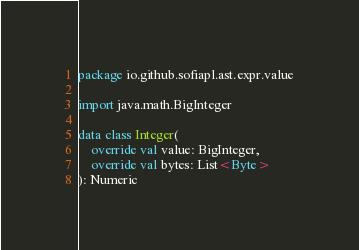Convert code to text. <code><loc_0><loc_0><loc_500><loc_500><_Kotlin_>package io.github.sofiapl.ast.expr.value

import java.math.BigInteger

data class Integer(
    override val value: BigInteger,
    override val bytes: List<Byte>
): Numeric
</code> 